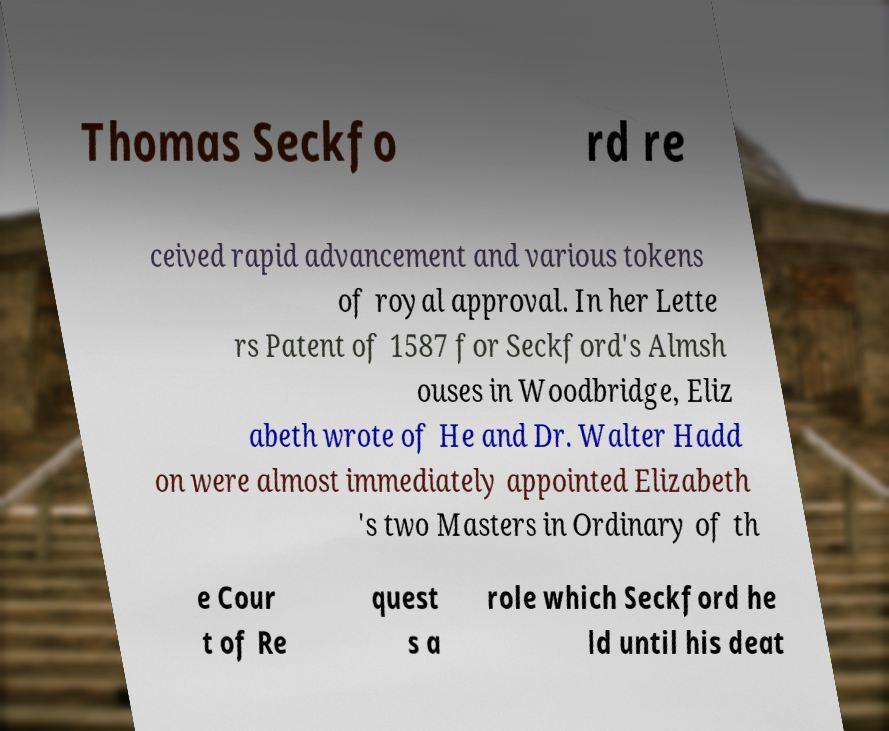There's text embedded in this image that I need extracted. Can you transcribe it verbatim? Thomas Seckfo rd re ceived rapid advancement and various tokens of royal approval. In her Lette rs Patent of 1587 for Seckford's Almsh ouses in Woodbridge, Eliz abeth wrote of He and Dr. Walter Hadd on were almost immediately appointed Elizabeth 's two Masters in Ordinary of th e Cour t of Re quest s a role which Seckford he ld until his deat 